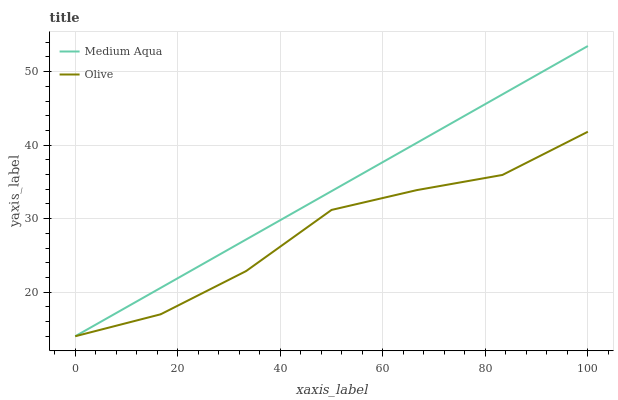Does Olive have the minimum area under the curve?
Answer yes or no. Yes. Does Medium Aqua have the maximum area under the curve?
Answer yes or no. Yes. Does Medium Aqua have the minimum area under the curve?
Answer yes or no. No. Is Medium Aqua the smoothest?
Answer yes or no. Yes. Is Olive the roughest?
Answer yes or no. Yes. Is Medium Aqua the roughest?
Answer yes or no. No. Does Olive have the lowest value?
Answer yes or no. Yes. Does Medium Aqua have the highest value?
Answer yes or no. Yes. Does Olive intersect Medium Aqua?
Answer yes or no. Yes. Is Olive less than Medium Aqua?
Answer yes or no. No. Is Olive greater than Medium Aqua?
Answer yes or no. No. 